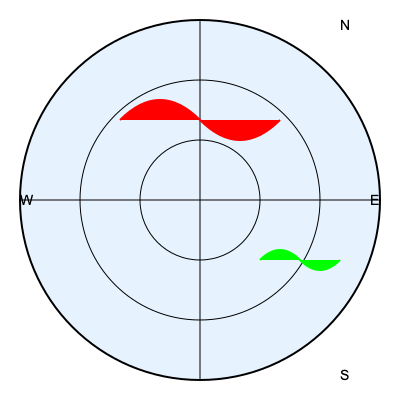Based on the weather radar image provided, which area presents the most significant potential hazard for your cargo flight, and what type of weather phenomenon does it likely represent? To interpret this weather radar image and identify potential hazards:

1. Orientation: The image is oriented with North at the top, East to the right, South at the bottom, and West to the left.

2. Color interpretation:
   - Red typically indicates areas of heavy precipitation or severe weather.
   - Green usually represents lighter precipitation or less severe weather.

3. Location and shape analysis:
   - There's a red, curved area in the northern quadrant of the radar.
   - A smaller green area is visible in the southeastern quadrant.

4. Weather phenomena interpretation:
   - The red, curved shape in the north is characteristic of a squall line or a strong cold front.
   - Squall lines often contain severe thunderstorms, strong winds, and possible tornadoes.
   - The green area likely represents lighter rain or less intense precipitation.

5. Hazard assessment:
   - The red area poses the most significant hazard due to its intensity and larger size.
   - Squall lines can produce turbulence, wind shear, hail, and lightning, all of which are dangerous for aircraft.

6. Flight implications:
   - As a cargo pilot, the northern area should be avoided if possible.
   - If the flight path intersects with this area, consider rerouting or delaying the flight.
   - The green area in the southeast is less concerning but should still be monitored.

Therefore, the northern area (red) presents the most significant potential hazard and likely represents a squall line or strong cold front with severe thunderstorms.
Answer: Northern area; squall line/severe thunderstorms 